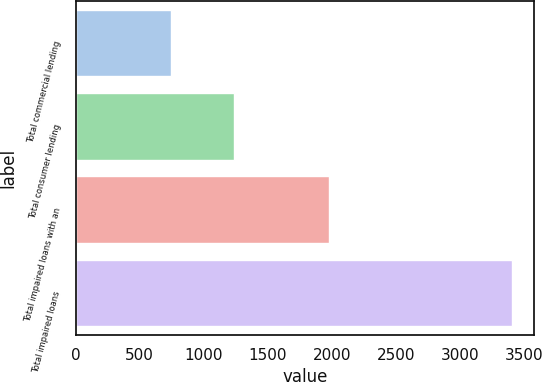Convert chart. <chart><loc_0><loc_0><loc_500><loc_500><bar_chart><fcel>Total commercial lending<fcel>Total consumer lending<fcel>Total impaired loans with an<fcel>Total impaired loans<nl><fcel>742<fcel>1237<fcel>1979<fcel>3408<nl></chart> 